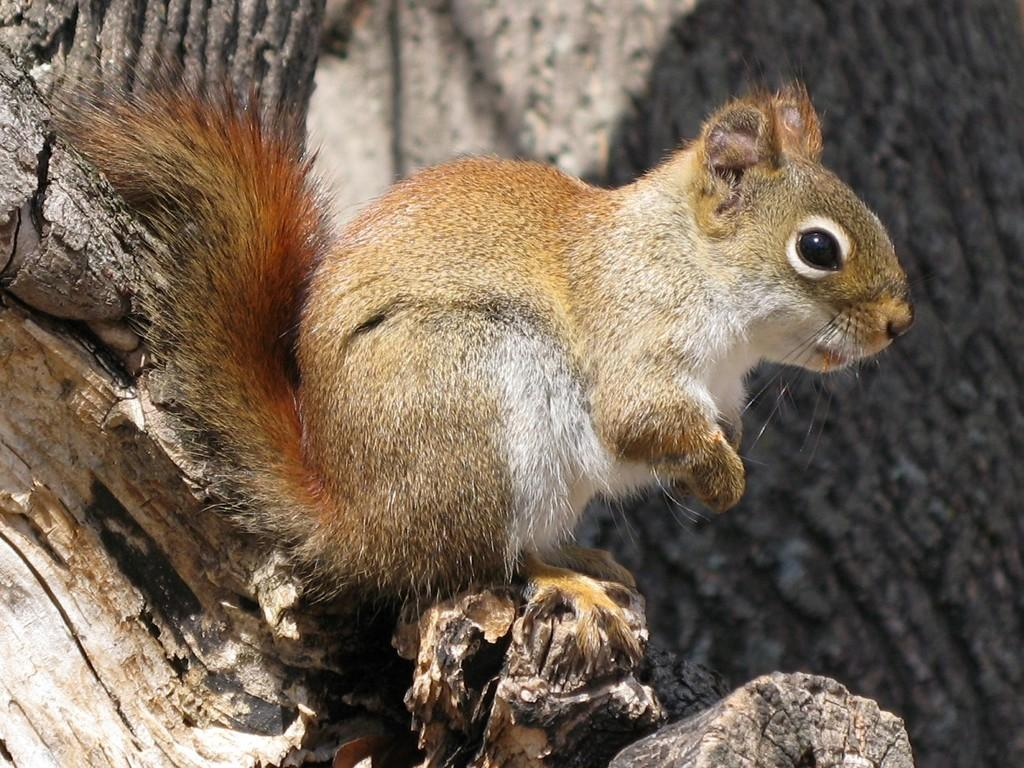What animal is present in the image? There is a squirrel in the image. What colors can be seen on the squirrel? The squirrel is white and brown in color. Where is the squirrel located in the image? The squirrel is on the trunk of a tree. How would you describe the background of the image? The background of the image is blurred. Is there a collar visible on the squirrel in the image? No, there is no collar visible on the squirrel in the image. 